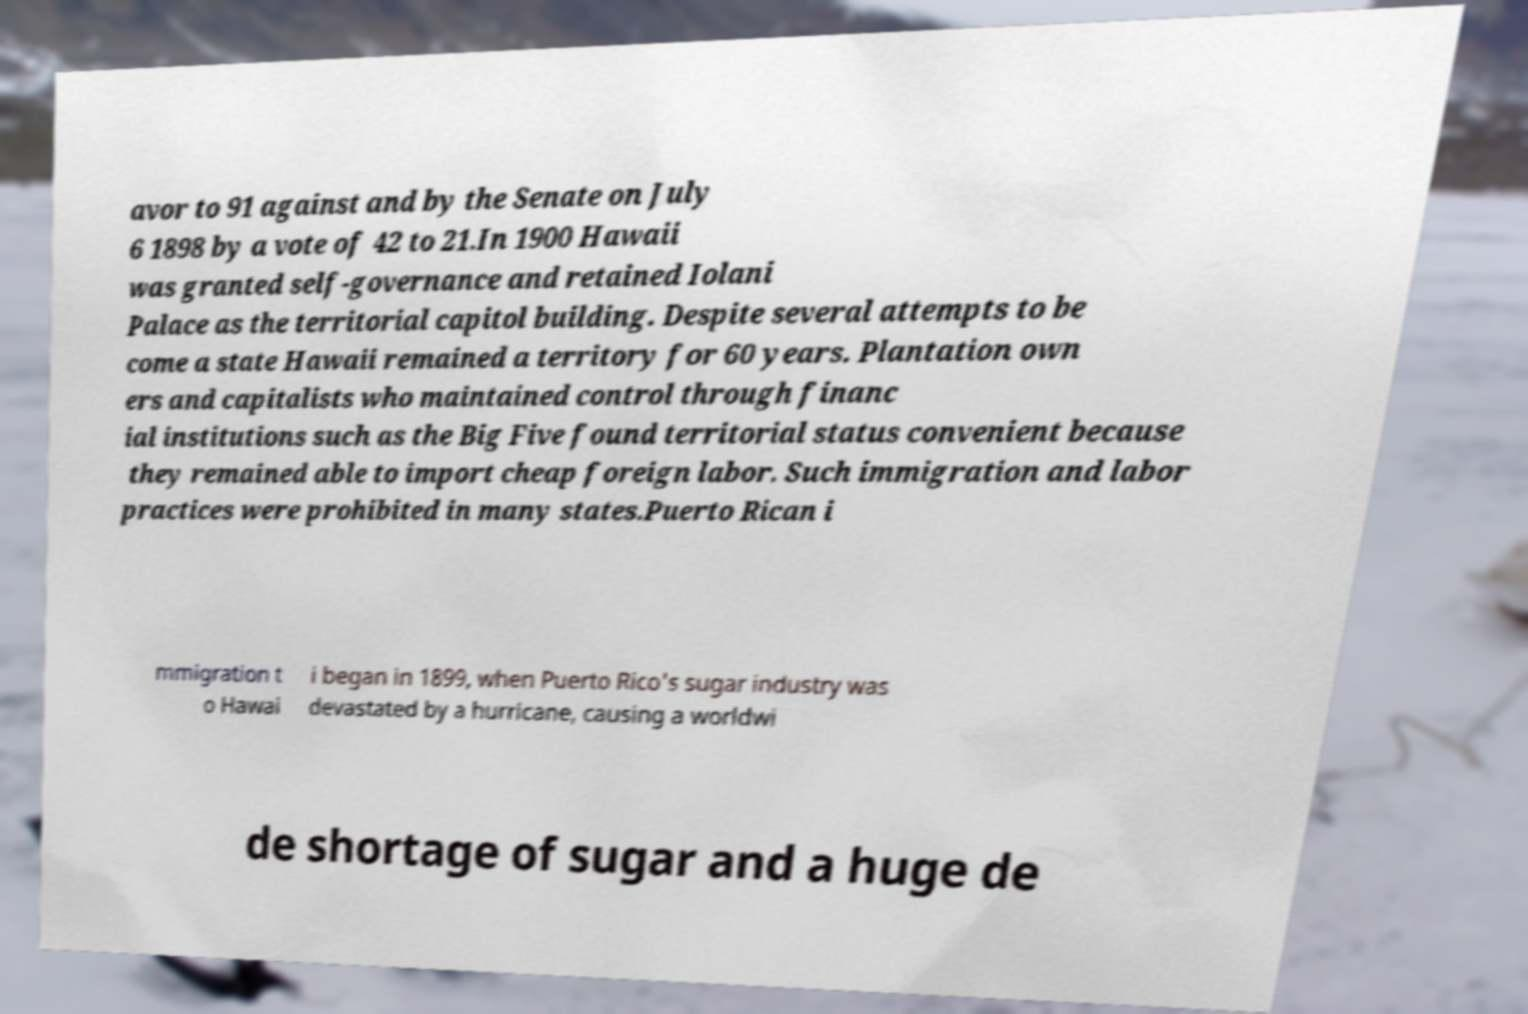For documentation purposes, I need the text within this image transcribed. Could you provide that? avor to 91 against and by the Senate on July 6 1898 by a vote of 42 to 21.In 1900 Hawaii was granted self-governance and retained Iolani Palace as the territorial capitol building. Despite several attempts to be come a state Hawaii remained a territory for 60 years. Plantation own ers and capitalists who maintained control through financ ial institutions such as the Big Five found territorial status convenient because they remained able to import cheap foreign labor. Such immigration and labor practices were prohibited in many states.Puerto Rican i mmigration t o Hawai i began in 1899, when Puerto Rico's sugar industry was devastated by a hurricane, causing a worldwi de shortage of sugar and a huge de 